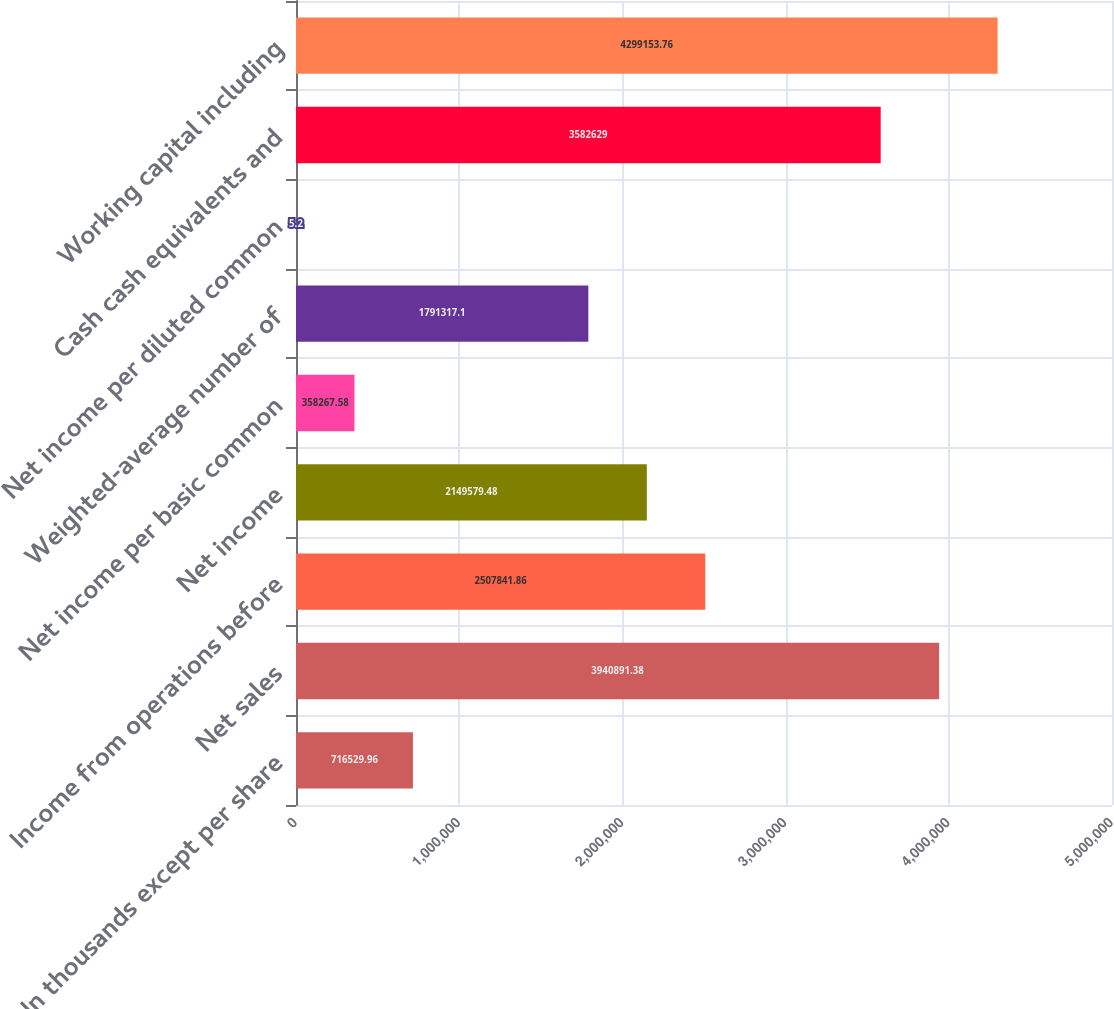Convert chart to OTSL. <chart><loc_0><loc_0><loc_500><loc_500><bar_chart><fcel>In thousands except per share<fcel>Net sales<fcel>Income from operations before<fcel>Net income<fcel>Net income per basic common<fcel>Weighted-average number of<fcel>Net income per diluted common<fcel>Cash cash equivalents and<fcel>Working capital including<nl><fcel>716530<fcel>3.94089e+06<fcel>2.50784e+06<fcel>2.14958e+06<fcel>358268<fcel>1.79132e+06<fcel>5.2<fcel>3.58263e+06<fcel>4.29915e+06<nl></chart> 